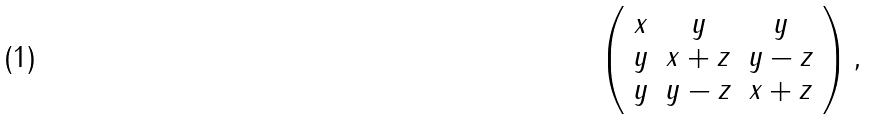Convert formula to latex. <formula><loc_0><loc_0><loc_500><loc_500>\left ( \begin{array} { c c c } x & y & y \\ y & x + z & y - z \\ y & y - z & x + z \end{array} \right ) ,</formula> 